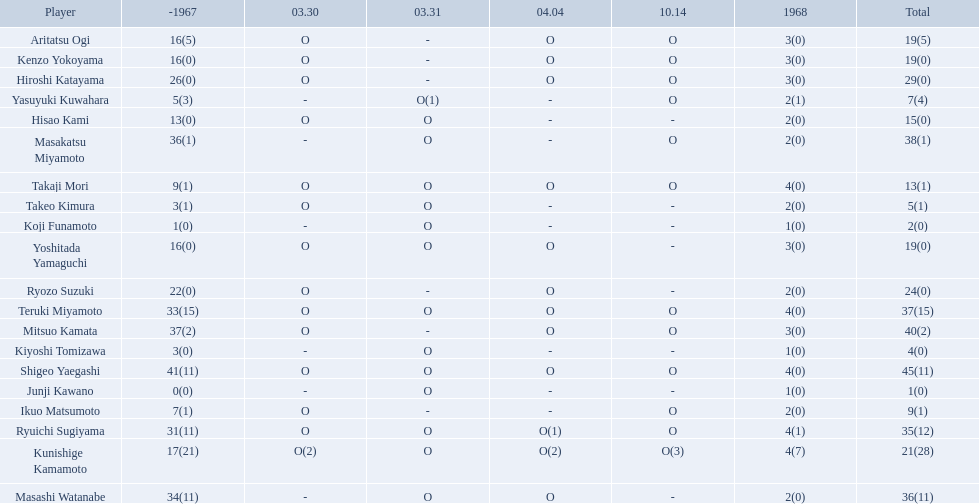Who are all of the players? Shigeo Yaegashi, Mitsuo Kamata, Masakatsu Miyamoto, Masashi Watanabe, Teruki Miyamoto, Ryuichi Sugiyama, Hiroshi Katayama, Ryozo Suzuki, Kunishige Kamamoto, Aritatsu Ogi, Yoshitada Yamaguchi, Kenzo Yokoyama, Hisao Kami, Takaji Mori, Ikuo Matsumoto, Yasuyuki Kuwahara, Takeo Kimura, Kiyoshi Tomizawa, Koji Funamoto, Junji Kawano. How many points did they receive? 45(11), 40(2), 38(1), 36(11), 37(15), 35(12), 29(0), 24(0), 21(28), 19(5), 19(0), 19(0), 15(0), 13(1), 9(1), 7(4), 5(1), 4(0), 2(0), 1(0). What about just takaji mori and junji kawano? 13(1), 1(0). Of the two, who had more points? Takaji Mori. 